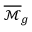Convert formula to latex. <formula><loc_0><loc_0><loc_500><loc_500>{ \overline { { \mathcal { M } } } } _ { g }</formula> 